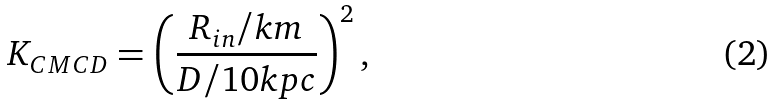<formula> <loc_0><loc_0><loc_500><loc_500>K _ { C M C D } = \left ( \frac { R _ { i n } / k m } { D / 1 0 k p c } \right ) ^ { 2 } ,</formula> 